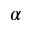<formula> <loc_0><loc_0><loc_500><loc_500>\alpha</formula> 